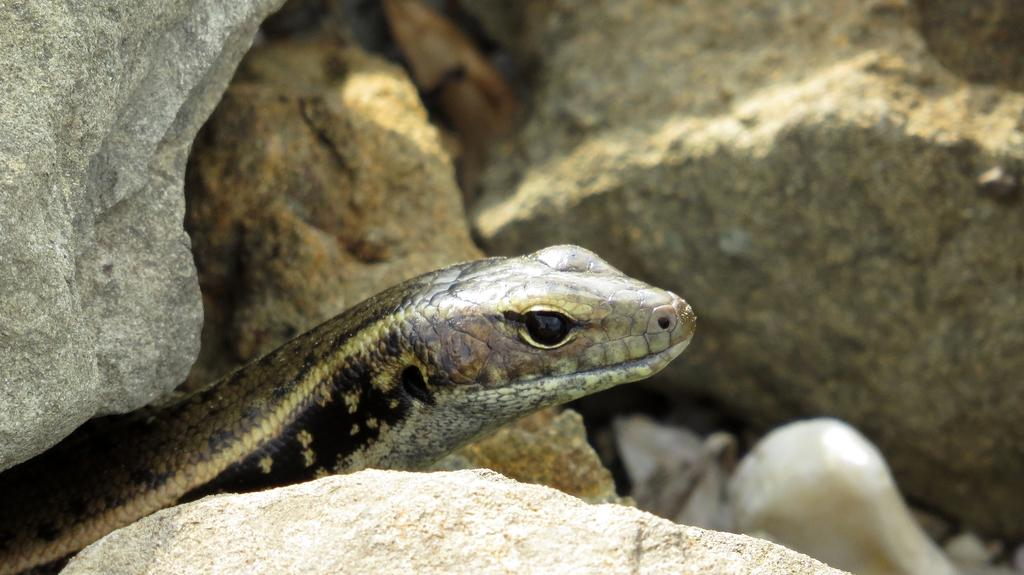What is the main subject in the center of the image? There is a snake in the center of the image. What can be seen in the background of the image? There are rocks in the background of the image. What is the snake arguing with the rocks about in the image? There is no indication of an argument or any communication between the snake and the rocks in the image. 